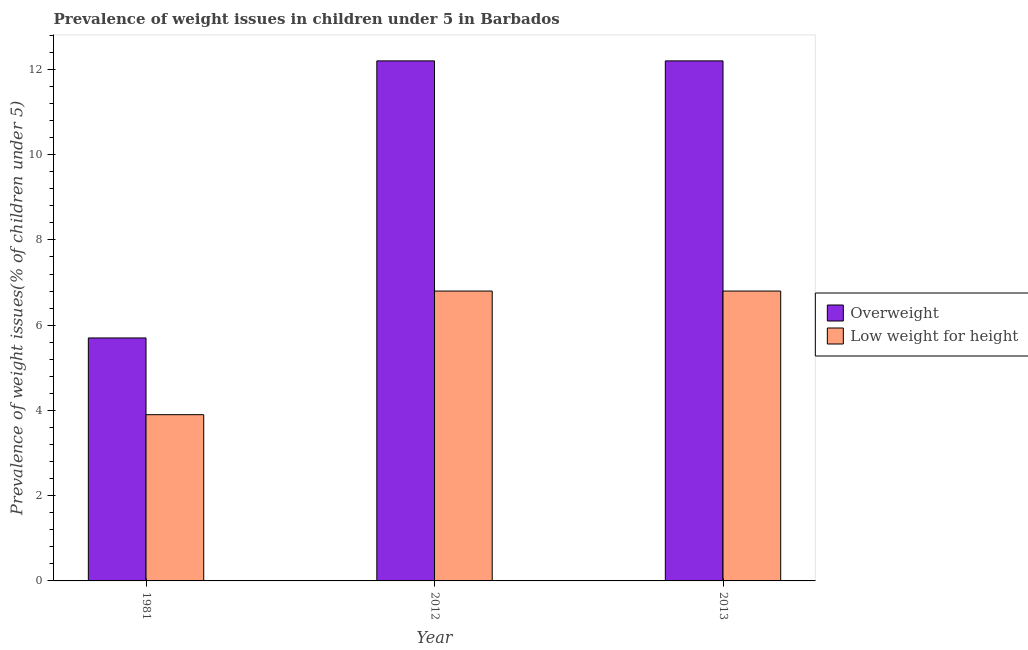How many groups of bars are there?
Offer a terse response. 3. Are the number of bars on each tick of the X-axis equal?
Keep it short and to the point. Yes. How many bars are there on the 1st tick from the left?
Your response must be concise. 2. How many bars are there on the 3rd tick from the right?
Give a very brief answer. 2. In how many cases, is the number of bars for a given year not equal to the number of legend labels?
Offer a terse response. 0. What is the percentage of underweight children in 1981?
Give a very brief answer. 3.9. Across all years, what is the maximum percentage of underweight children?
Make the answer very short. 6.8. Across all years, what is the minimum percentage of overweight children?
Provide a short and direct response. 5.7. In which year was the percentage of overweight children maximum?
Offer a terse response. 2013. What is the total percentage of underweight children in the graph?
Your answer should be compact. 17.5. What is the difference between the percentage of underweight children in 1981 and that in 2012?
Provide a short and direct response. -2.9. What is the difference between the percentage of overweight children in 2012 and the percentage of underweight children in 2013?
Provide a succinct answer. -1.907348998742009e-7. What is the average percentage of underweight children per year?
Ensure brevity in your answer.  5.83. In the year 1981, what is the difference between the percentage of underweight children and percentage of overweight children?
Your response must be concise. 0. In how many years, is the percentage of overweight children greater than 10 %?
Provide a short and direct response. 2. What is the ratio of the percentage of overweight children in 1981 to that in 2013?
Your answer should be very brief. 0.47. What is the difference between the highest and the second highest percentage of underweight children?
Your answer should be compact. 1.9073486079435042e-7. What is the difference between the highest and the lowest percentage of overweight children?
Keep it short and to the point. 6.5. In how many years, is the percentage of overweight children greater than the average percentage of overweight children taken over all years?
Give a very brief answer. 2. What does the 1st bar from the left in 2012 represents?
Offer a very short reply. Overweight. What does the 1st bar from the right in 2013 represents?
Give a very brief answer. Low weight for height. Are all the bars in the graph horizontal?
Make the answer very short. No. What is the difference between two consecutive major ticks on the Y-axis?
Give a very brief answer. 2. Are the values on the major ticks of Y-axis written in scientific E-notation?
Offer a terse response. No. Does the graph contain any zero values?
Offer a very short reply. No. How many legend labels are there?
Make the answer very short. 2. What is the title of the graph?
Your answer should be compact. Prevalence of weight issues in children under 5 in Barbados. Does "Food and tobacco" appear as one of the legend labels in the graph?
Your answer should be very brief. No. What is the label or title of the X-axis?
Your answer should be compact. Year. What is the label or title of the Y-axis?
Keep it short and to the point. Prevalence of weight issues(% of children under 5). What is the Prevalence of weight issues(% of children under 5) in Overweight in 1981?
Give a very brief answer. 5.7. What is the Prevalence of weight issues(% of children under 5) in Low weight for height in 1981?
Give a very brief answer. 3.9. What is the Prevalence of weight issues(% of children under 5) in Overweight in 2012?
Give a very brief answer. 12.2. What is the Prevalence of weight issues(% of children under 5) of Low weight for height in 2012?
Offer a terse response. 6.8. What is the Prevalence of weight issues(% of children under 5) in Overweight in 2013?
Offer a very short reply. 12.2. What is the Prevalence of weight issues(% of children under 5) in Low weight for height in 2013?
Ensure brevity in your answer.  6.8. Across all years, what is the maximum Prevalence of weight issues(% of children under 5) of Overweight?
Ensure brevity in your answer.  12.2. Across all years, what is the maximum Prevalence of weight issues(% of children under 5) of Low weight for height?
Provide a short and direct response. 6.8. Across all years, what is the minimum Prevalence of weight issues(% of children under 5) in Overweight?
Offer a terse response. 5.7. Across all years, what is the minimum Prevalence of weight issues(% of children under 5) of Low weight for height?
Your answer should be compact. 3.9. What is the total Prevalence of weight issues(% of children under 5) of Overweight in the graph?
Your response must be concise. 30.1. What is the difference between the Prevalence of weight issues(% of children under 5) in Low weight for height in 1981 and that in 2012?
Provide a succinct answer. -2.9. What is the difference between the Prevalence of weight issues(% of children under 5) in Low weight for height in 1981 and that in 2013?
Offer a terse response. -2.9. What is the difference between the Prevalence of weight issues(% of children under 5) in Overweight in 2012 and that in 2013?
Give a very brief answer. -0. What is the difference between the Prevalence of weight issues(% of children under 5) in Low weight for height in 2012 and that in 2013?
Your answer should be compact. 0. What is the difference between the Prevalence of weight issues(% of children under 5) in Overweight in 1981 and the Prevalence of weight issues(% of children under 5) in Low weight for height in 2012?
Your response must be concise. -1.1. What is the difference between the Prevalence of weight issues(% of children under 5) in Overweight in 1981 and the Prevalence of weight issues(% of children under 5) in Low weight for height in 2013?
Provide a short and direct response. -1.1. What is the average Prevalence of weight issues(% of children under 5) in Overweight per year?
Make the answer very short. 10.03. What is the average Prevalence of weight issues(% of children under 5) of Low weight for height per year?
Ensure brevity in your answer.  5.83. In the year 1981, what is the difference between the Prevalence of weight issues(% of children under 5) in Overweight and Prevalence of weight issues(% of children under 5) in Low weight for height?
Keep it short and to the point. 1.8. In the year 2012, what is the difference between the Prevalence of weight issues(% of children under 5) of Overweight and Prevalence of weight issues(% of children under 5) of Low weight for height?
Ensure brevity in your answer.  5.4. In the year 2013, what is the difference between the Prevalence of weight issues(% of children under 5) in Overweight and Prevalence of weight issues(% of children under 5) in Low weight for height?
Provide a short and direct response. 5.4. What is the ratio of the Prevalence of weight issues(% of children under 5) of Overweight in 1981 to that in 2012?
Your response must be concise. 0.47. What is the ratio of the Prevalence of weight issues(% of children under 5) of Low weight for height in 1981 to that in 2012?
Provide a succinct answer. 0.57. What is the ratio of the Prevalence of weight issues(% of children under 5) of Overweight in 1981 to that in 2013?
Make the answer very short. 0.47. What is the ratio of the Prevalence of weight issues(% of children under 5) in Low weight for height in 1981 to that in 2013?
Offer a terse response. 0.57. What is the ratio of the Prevalence of weight issues(% of children under 5) in Overweight in 2012 to that in 2013?
Your response must be concise. 1. What is the ratio of the Prevalence of weight issues(% of children under 5) in Low weight for height in 2012 to that in 2013?
Offer a terse response. 1. What is the difference between the highest and the second highest Prevalence of weight issues(% of children under 5) in Overweight?
Keep it short and to the point. 0. What is the difference between the highest and the second highest Prevalence of weight issues(% of children under 5) in Low weight for height?
Offer a very short reply. 0. What is the difference between the highest and the lowest Prevalence of weight issues(% of children under 5) in Low weight for height?
Provide a succinct answer. 2.9. 